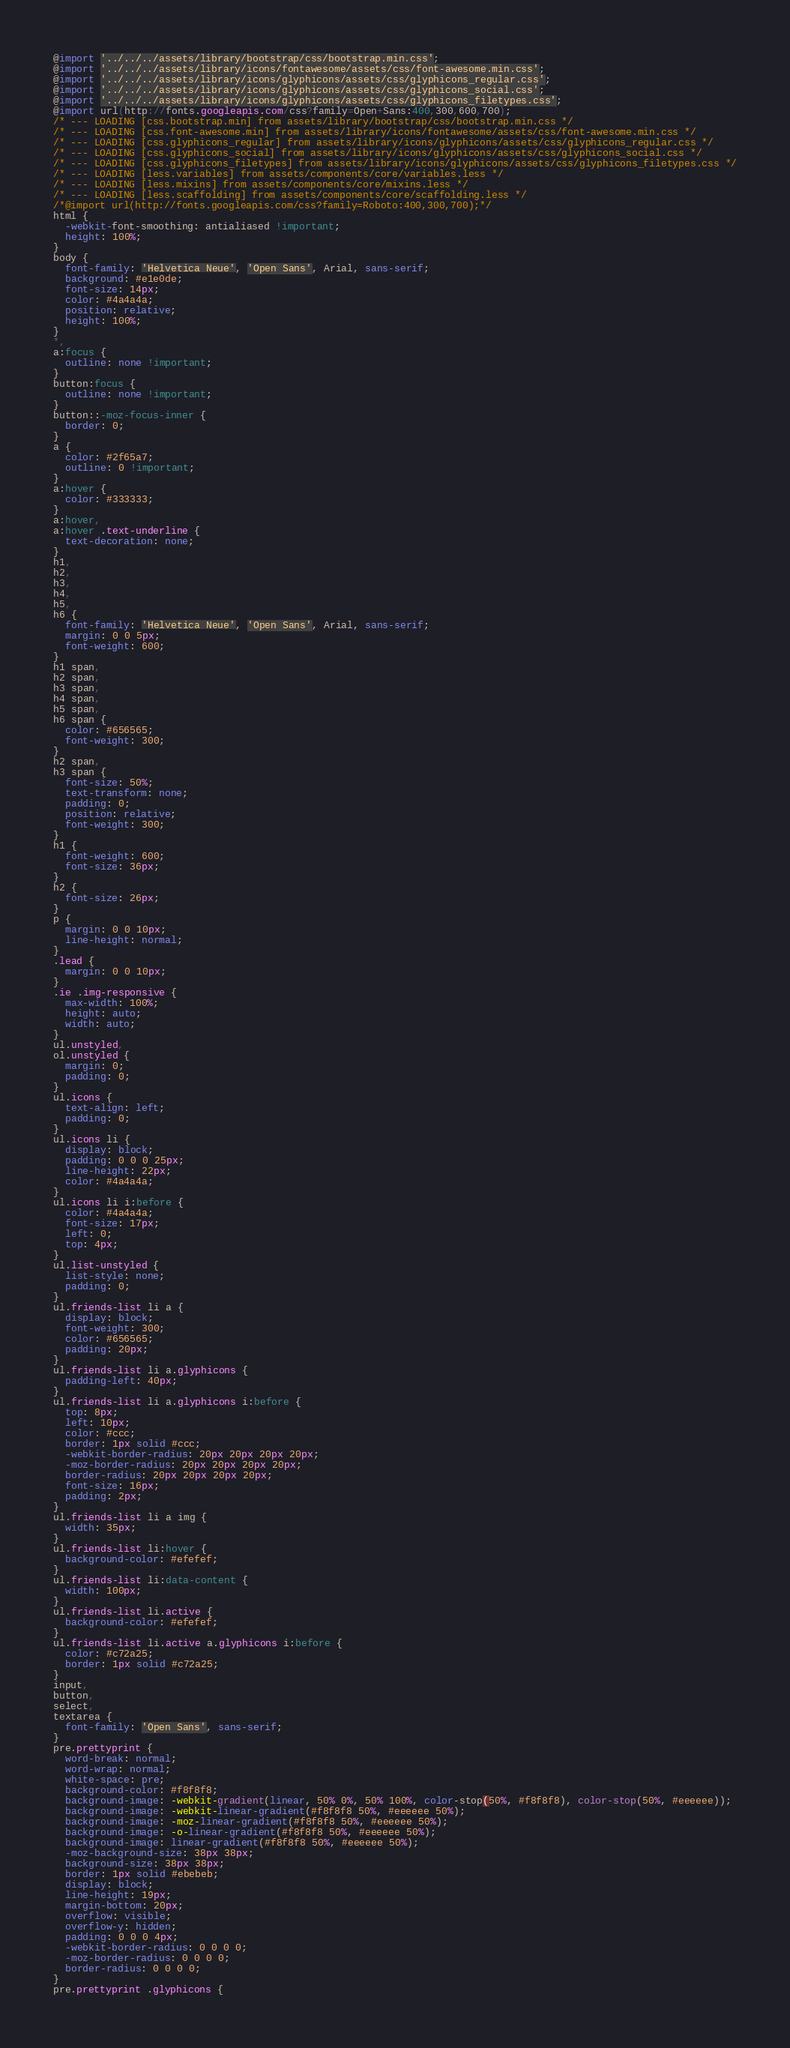<code> <loc_0><loc_0><loc_500><loc_500><_CSS_>@import '../../../assets/library/bootstrap/css/bootstrap.min.css';
@import '../../../assets/library/icons/fontawesome/assets/css/font-awesome.min.css';
@import '../../../assets/library/icons/glyphicons/assets/css/glyphicons_regular.css';
@import '../../../assets/library/icons/glyphicons/assets/css/glyphicons_social.css';
@import '../../../assets/library/icons/glyphicons/assets/css/glyphicons_filetypes.css';
@import url(http://fonts.googleapis.com/css?family=Open+Sans:400,300,600,700);
/* --- LOADING [css.bootstrap.min] from assets/library/bootstrap/css/bootstrap.min.css */
/* --- LOADING [css.font-awesome.min] from assets/library/icons/fontawesome/assets/css/font-awesome.min.css */
/* --- LOADING [css.glyphicons_regular] from assets/library/icons/glyphicons/assets/css/glyphicons_regular.css */
/* --- LOADING [css.glyphicons_social] from assets/library/icons/glyphicons/assets/css/glyphicons_social.css */
/* --- LOADING [css.glyphicons_filetypes] from assets/library/icons/glyphicons/assets/css/glyphicons_filetypes.css */
/* --- LOADING [less.variables] from assets/components/core/variables.less */
/* --- LOADING [less.mixins] from assets/components/core/mixins.less */
/* --- LOADING [less.scaffolding] from assets/components/core/scaffolding.less */
/*@import url(http://fonts.googleapis.com/css?family=Roboto:400,300,700);*/
html {
  -webkit-font-smoothing: antialiased !important;
  height: 100%;
}
body {
  font-family: 'Helvetica Neue', 'Open Sans', Arial, sans-serif;
  background: #e1e0de;
  font-size: 14px;
  color: #4a4a4a;
  position: relative;
  height: 100%;
}
*,
a:focus {
  outline: none !important;
}
button:focus {
  outline: none !important;
}
button::-moz-focus-inner {
  border: 0;
}
a {
  color: #2f65a7;
  outline: 0 !important;
}
a:hover {
  color: #333333;
}
a:hover,
a:hover .text-underline {
  text-decoration: none;
}
h1,
h2,
h3,
h4,
h5,
h6 {
  font-family: 'Helvetica Neue', 'Open Sans', Arial, sans-serif;
  margin: 0 0 5px;
  font-weight: 600;
}
h1 span,
h2 span,
h3 span,
h4 span,
h5 span,
h6 span {
  color: #656565;
  font-weight: 300;
}
h2 span,
h3 span {
  font-size: 50%;
  text-transform: none;
  padding: 0;
  position: relative;
  font-weight: 300;
}
h1 {
  font-weight: 600;
  font-size: 36px;
}
h2 {
  font-size: 26px;
}
p {
  margin: 0 0 10px;
  line-height: normal;
}
.lead {
  margin: 0 0 10px;
}
.ie .img-responsive {
  max-width: 100%;
  height: auto;
  width: auto;
}
ul.unstyled,
ol.unstyled {
  margin: 0;
  padding: 0;
}
ul.icons {
  text-align: left;
  padding: 0;
}
ul.icons li {
  display: block;
  padding: 0 0 0 25px;
  line-height: 22px;
  color: #4a4a4a;
}
ul.icons li i:before {
  color: #4a4a4a;
  font-size: 17px;
  left: 0;
  top: 4px;
}
ul.list-unstyled {
  list-style: none;
  padding: 0;
}
ul.friends-list li a {
  display: block;
  font-weight: 300;
  color: #656565;
  padding: 20px;
}
ul.friends-list li a.glyphicons {
  padding-left: 40px;
}
ul.friends-list li a.glyphicons i:before {
  top: 8px;
  left: 10px;
  color: #ccc;
  border: 1px solid #ccc;
  -webkit-border-radius: 20px 20px 20px 20px;
  -moz-border-radius: 20px 20px 20px 20px;
  border-radius: 20px 20px 20px 20px;
  font-size: 16px;
  padding: 2px;
}
ul.friends-list li a img {
  width: 35px;
}
ul.friends-list li:hover {
  background-color: #efefef;
}
ul.friends-list li:data-content {
  width: 100px;
}
ul.friends-list li.active {
  background-color: #efefef;
}
ul.friends-list li.active a.glyphicons i:before {
  color: #c72a25;
  border: 1px solid #c72a25;
}
input,
button,
select,
textarea {
  font-family: 'Open Sans', sans-serif;
}
pre.prettyprint {
  word-break: normal;
  word-wrap: normal;
  white-space: pre;
  background-color: #f8f8f8;
  background-image: -webkit-gradient(linear, 50% 0%, 50% 100%, color-stop(50%, #f8f8f8), color-stop(50%, #eeeeee));
  background-image: -webkit-linear-gradient(#f8f8f8 50%, #eeeeee 50%);
  background-image: -moz-linear-gradient(#f8f8f8 50%, #eeeeee 50%);
  background-image: -o-linear-gradient(#f8f8f8 50%, #eeeeee 50%);
  background-image: linear-gradient(#f8f8f8 50%, #eeeeee 50%);
  -moz-background-size: 38px 38px;
  background-size: 38px 38px;
  border: 1px solid #ebebeb;
  display: block;
  line-height: 19px;
  margin-bottom: 20px;
  overflow: visible;
  overflow-y: hidden;
  padding: 0 0 0 4px;
  -webkit-border-radius: 0 0 0 0;
  -moz-border-radius: 0 0 0 0;
  border-radius: 0 0 0 0;
}
pre.prettyprint .glyphicons {</code> 